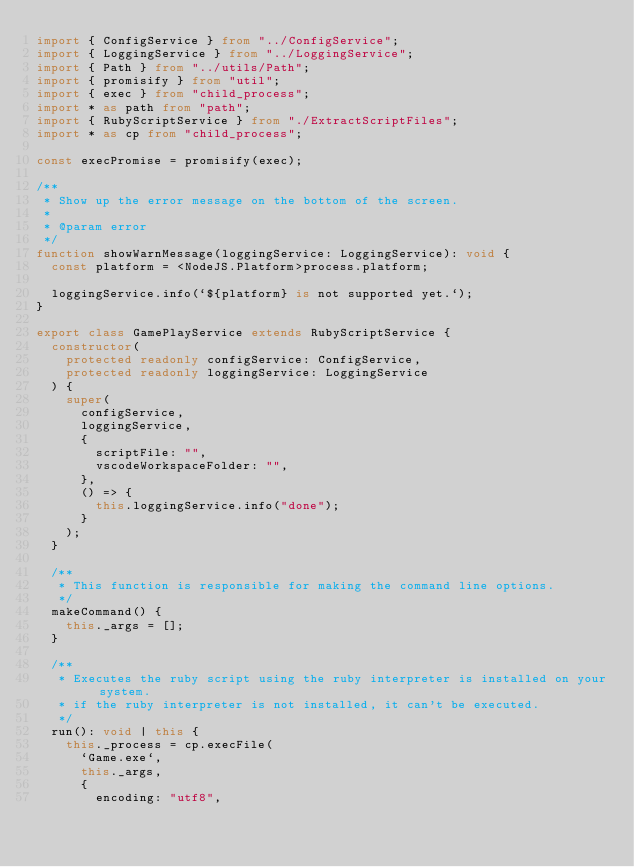Convert code to text. <code><loc_0><loc_0><loc_500><loc_500><_TypeScript_>import { ConfigService } from "../ConfigService";
import { LoggingService } from "../LoggingService";
import { Path } from "../utils/Path";
import { promisify } from "util";
import { exec } from "child_process";
import * as path from "path";
import { RubyScriptService } from "./ExtractScriptFiles";
import * as cp from "child_process";

const execPromise = promisify(exec);

/**
 * Show up the error message on the bottom of the screen.
 *
 * @param error
 */
function showWarnMessage(loggingService: LoggingService): void {
  const platform = <NodeJS.Platform>process.platform;

  loggingService.info(`${platform} is not supported yet.`);
}

export class GamePlayService extends RubyScriptService {
  constructor(
    protected readonly configService: ConfigService,
    protected readonly loggingService: LoggingService
  ) {
    super(
      configService,
      loggingService,
      {
        scriptFile: "",
        vscodeWorkspaceFolder: "",
      },
      () => {
        this.loggingService.info("done");
      }
    );
  }

  /**
   * This function is responsible for making the command line options.
   */
  makeCommand() {
    this._args = [];
  }

  /**
   * Executes the ruby script using the ruby interpreter is installed on your system.
   * if the ruby interpreter is not installed, it can't be executed.
   */
  run(): void | this {
    this._process = cp.execFile(
      `Game.exe`,
      this._args,
      {
        encoding: "utf8",</code> 